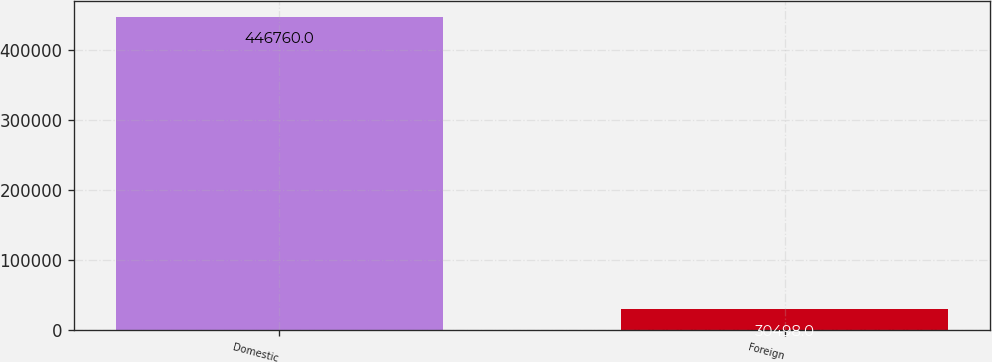Convert chart to OTSL. <chart><loc_0><loc_0><loc_500><loc_500><bar_chart><fcel>Domestic<fcel>Foreign<nl><fcel>446760<fcel>30498<nl></chart> 